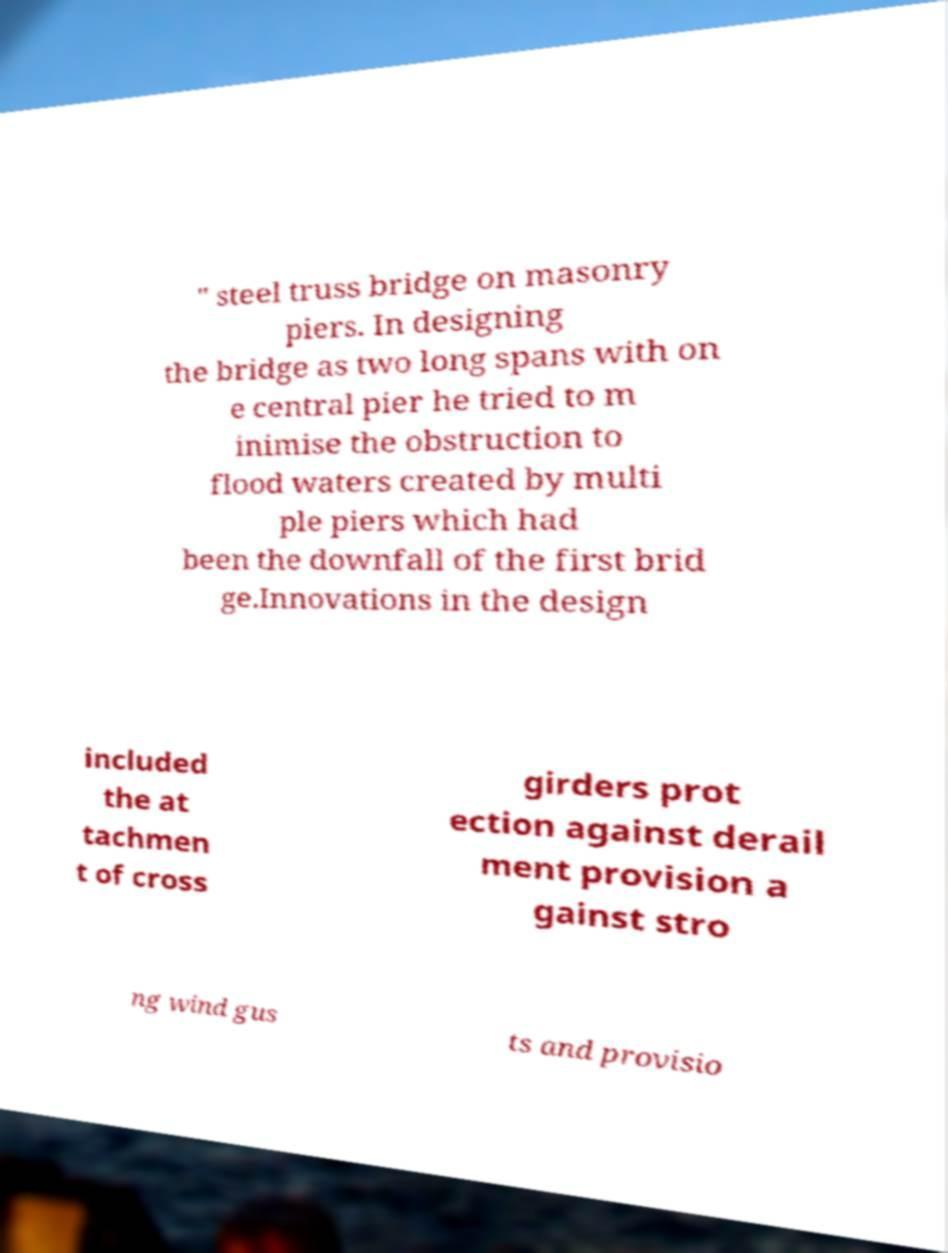Please read and relay the text visible in this image. What does it say? " steel truss bridge on masonry piers. In designing the bridge as two long spans with on e central pier he tried to m inimise the obstruction to flood waters created by multi ple piers which had been the downfall of the first brid ge.Innovations in the design included the at tachmen t of cross girders prot ection against derail ment provision a gainst stro ng wind gus ts and provisio 